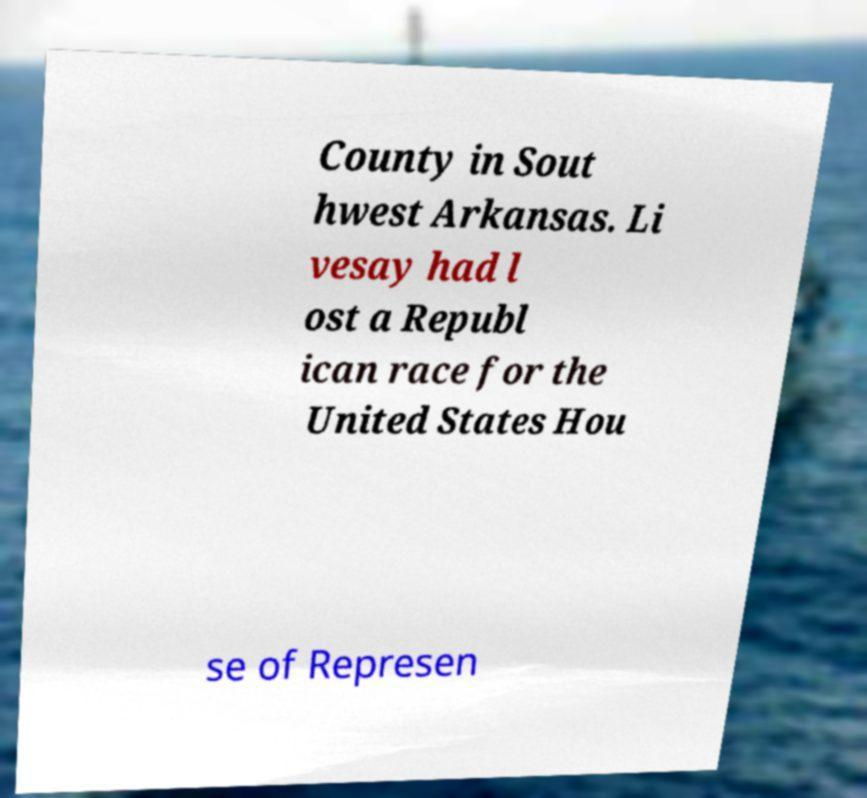I need the written content from this picture converted into text. Can you do that? County in Sout hwest Arkansas. Li vesay had l ost a Republ ican race for the United States Hou se of Represen 